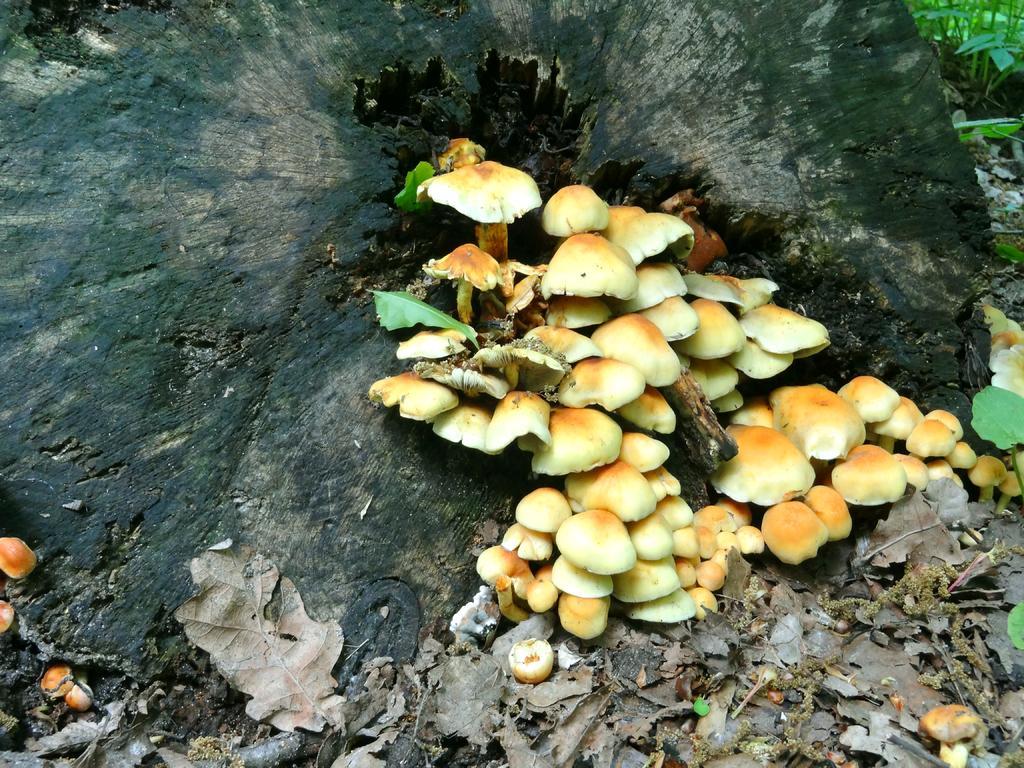Can you describe this image briefly? In this picture we can see a tree trunk, mushrooms, dried leaves and in the background we can see plants. 